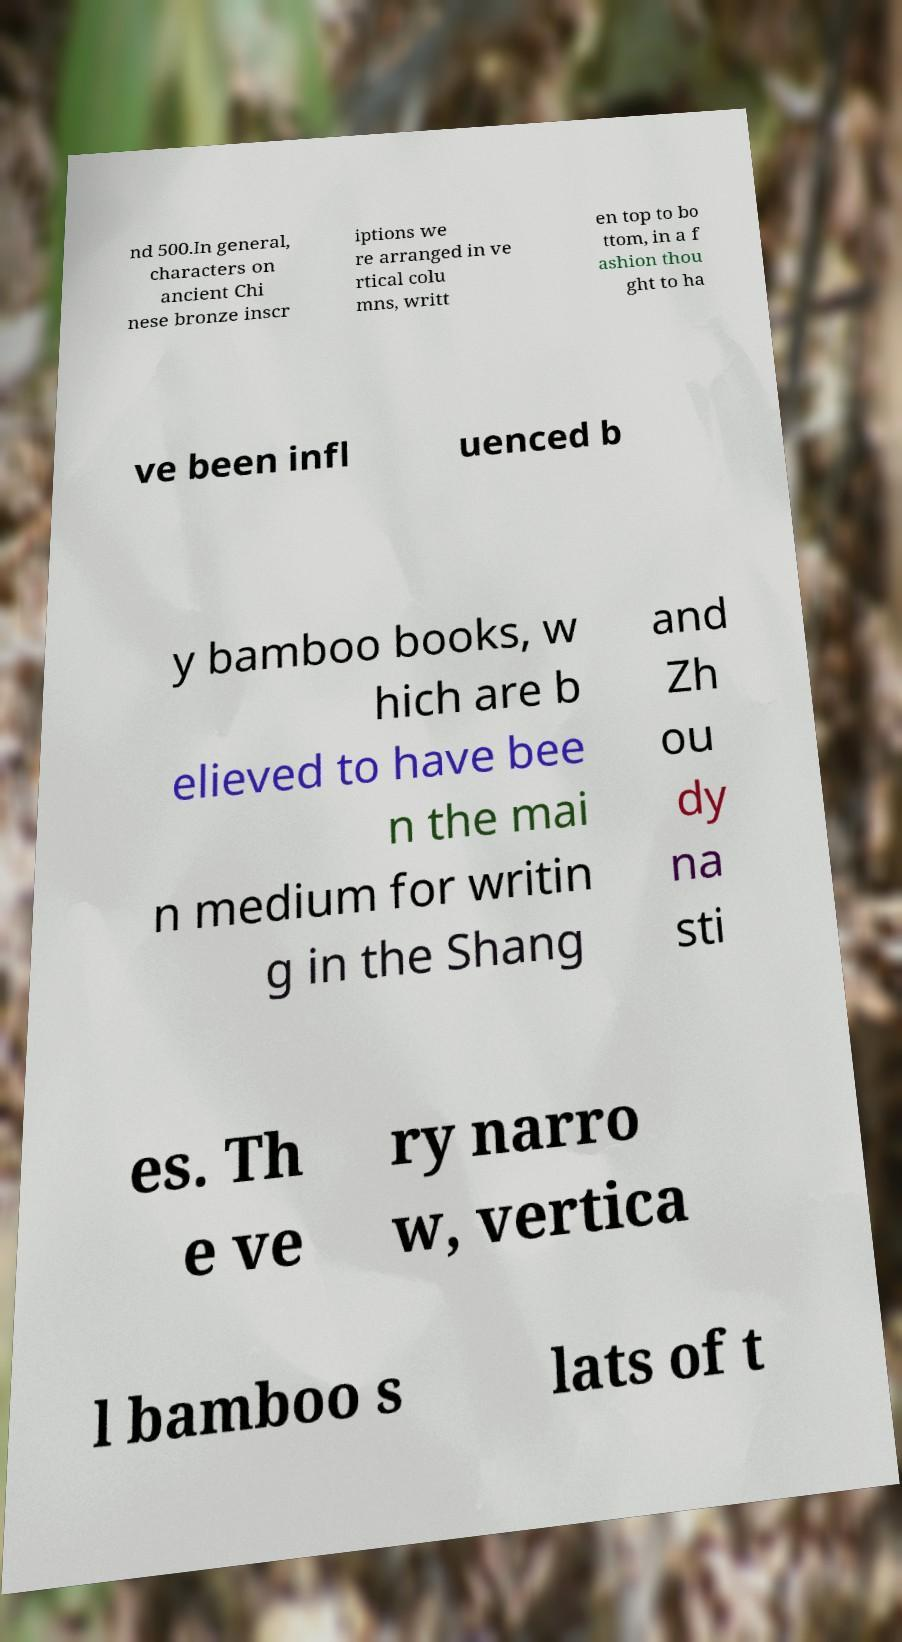What messages or text are displayed in this image? I need them in a readable, typed format. nd 500.In general, characters on ancient Chi nese bronze inscr iptions we re arranged in ve rtical colu mns, writt en top to bo ttom, in a f ashion thou ght to ha ve been infl uenced b y bamboo books, w hich are b elieved to have bee n the mai n medium for writin g in the Shang and Zh ou dy na sti es. Th e ve ry narro w, vertica l bamboo s lats of t 